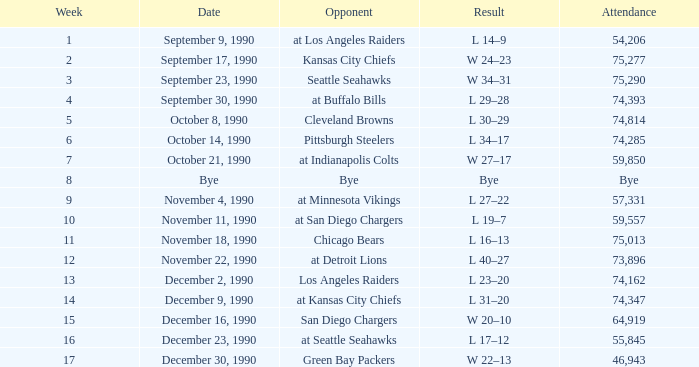What day was the attendance 74,285? October 14, 1990. 